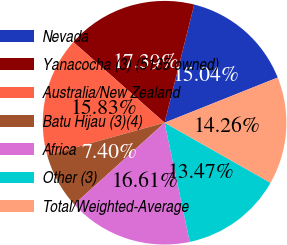Convert chart. <chart><loc_0><loc_0><loc_500><loc_500><pie_chart><fcel>Nevada<fcel>Yanacocha (3) (5135 owned)<fcel>Australia/New Zealand<fcel>Batu Hijau (3)(4)<fcel>Africa<fcel>Other (3)<fcel>Total/Weighted-Average<nl><fcel>15.04%<fcel>17.39%<fcel>15.83%<fcel>7.4%<fcel>16.61%<fcel>13.47%<fcel>14.26%<nl></chart> 